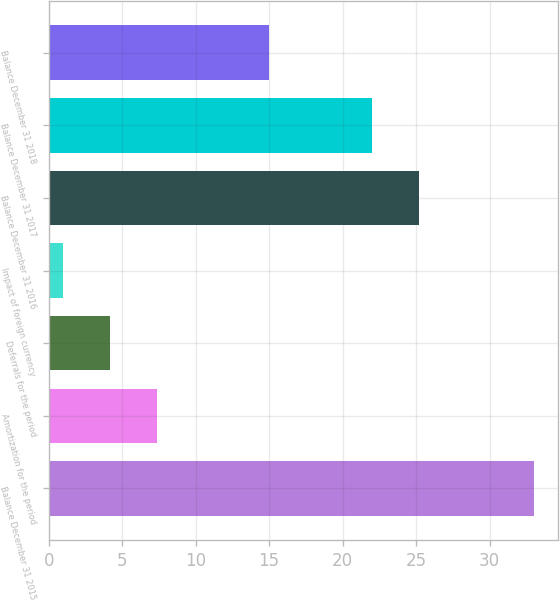Convert chart to OTSL. <chart><loc_0><loc_0><loc_500><loc_500><bar_chart><fcel>Balance December 31 2015<fcel>Amortization for the period<fcel>Deferrals for the period<fcel>Impact of foreign currency<fcel>Balance December 31 2016<fcel>Balance December 31 2017<fcel>Balance December 31 2018<nl><fcel>33<fcel>7.4<fcel>4.2<fcel>1<fcel>25.2<fcel>22<fcel>15<nl></chart> 